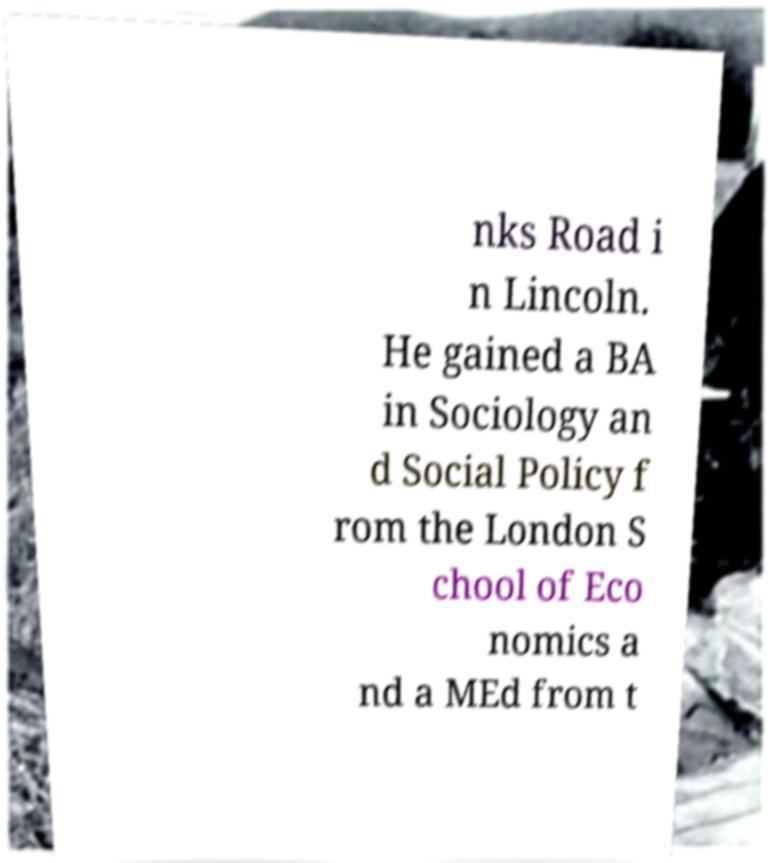Can you accurately transcribe the text from the provided image for me? nks Road i n Lincoln. He gained a BA in Sociology an d Social Policy f rom the London S chool of Eco nomics a nd a MEd from t 